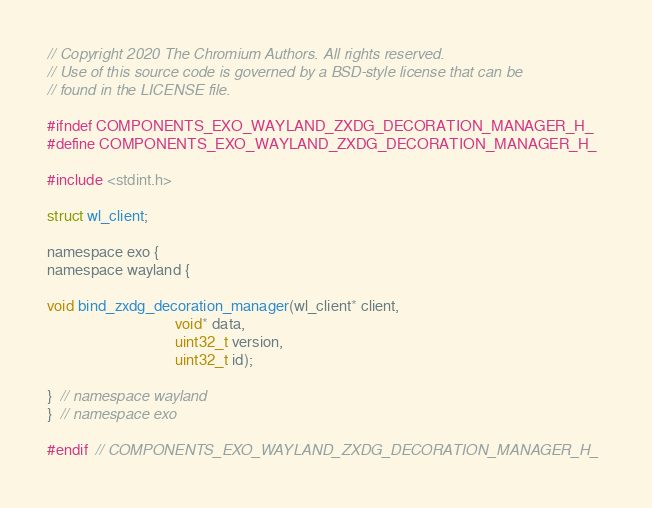Convert code to text. <code><loc_0><loc_0><loc_500><loc_500><_C_>// Copyright 2020 The Chromium Authors. All rights reserved.
// Use of this source code is governed by a BSD-style license that can be
// found in the LICENSE file.

#ifndef COMPONENTS_EXO_WAYLAND_ZXDG_DECORATION_MANAGER_H_
#define COMPONENTS_EXO_WAYLAND_ZXDG_DECORATION_MANAGER_H_

#include <stdint.h>

struct wl_client;

namespace exo {
namespace wayland {

void bind_zxdg_decoration_manager(wl_client* client,
                                  void* data,
                                  uint32_t version,
                                  uint32_t id);

}  // namespace wayland
}  // namespace exo

#endif  // COMPONENTS_EXO_WAYLAND_ZXDG_DECORATION_MANAGER_H_
</code> 